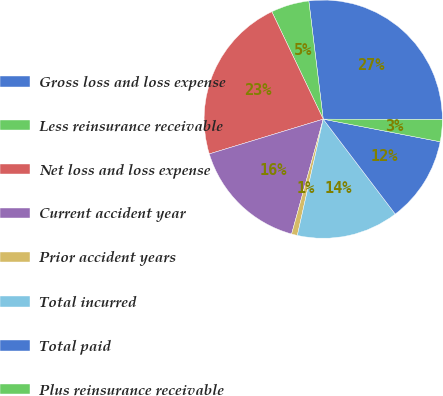Convert chart. <chart><loc_0><loc_0><loc_500><loc_500><pie_chart><fcel>Gross loss and loss expense<fcel>Less reinsurance receivable<fcel>Net loss and loss expense<fcel>Current accident year<fcel>Prior accident years<fcel>Total incurred<fcel>Total paid<fcel>Plus reinsurance receivable<nl><fcel>26.99%<fcel>5.17%<fcel>22.61%<fcel>16.01%<fcel>0.79%<fcel>13.82%<fcel>11.63%<fcel>2.98%<nl></chart> 